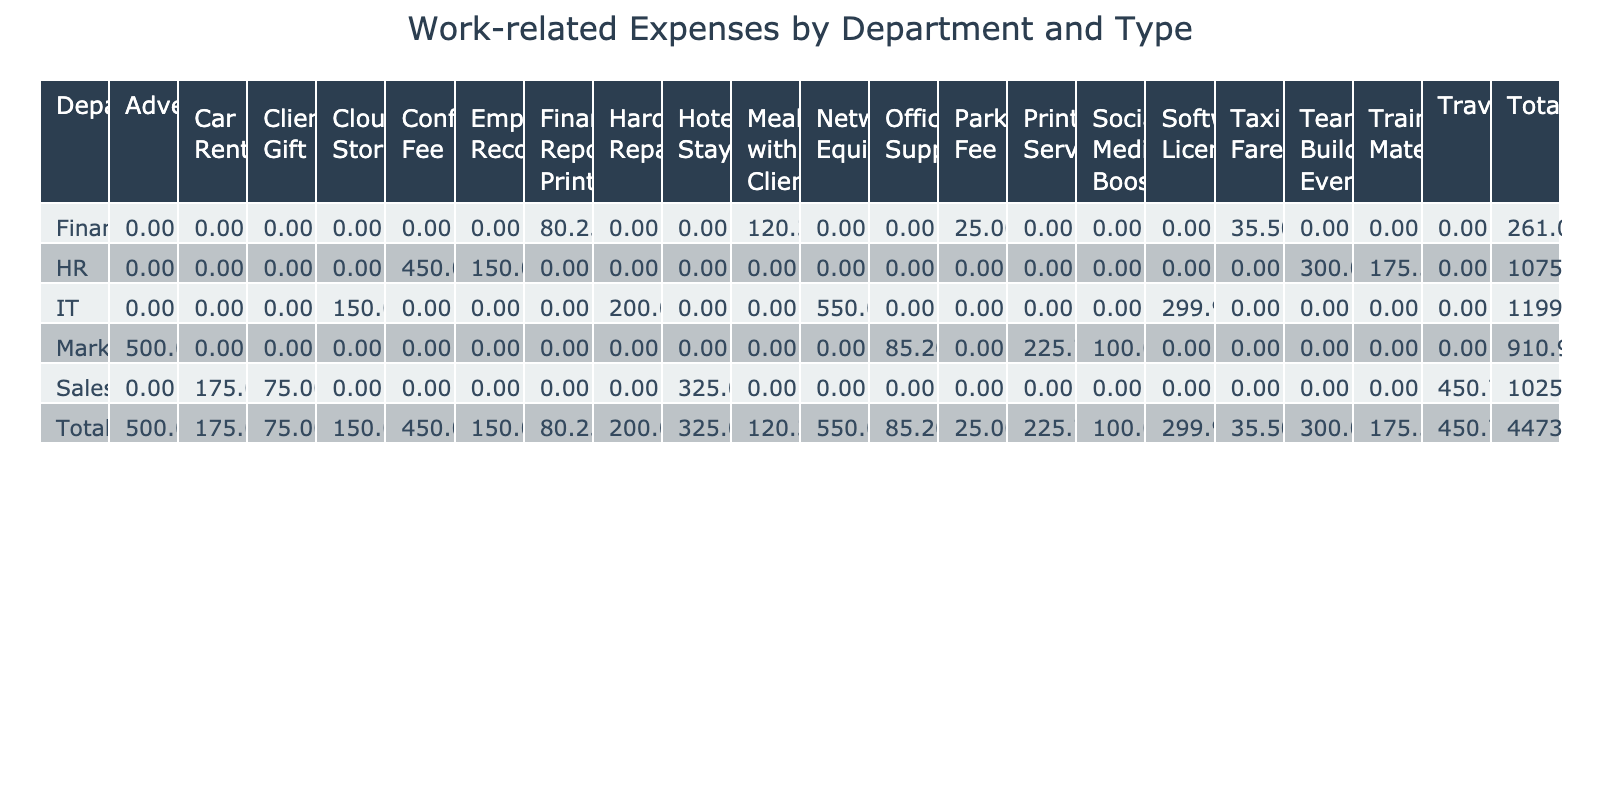What is the total amount spent by the HR department? The HR department has three entries: Training Materials for 175.50, Conference Fee for 450.00, and Employee Recognition for 150.00. Adding these amounts together gives 175.50 + 450.00 + 150.00 = 775.50.
Answer: 775.50 Which department had the highest total expenses? By inspecting the total column in the table, the IT department has the highest total at 1,665.00. The totals for each department are: Sales 1,026.75, Marketing 911.95, IT 1,665.00, HR 775.50, and Finance 260.80.
Answer: IT Was the expense for the Hotel Stay in the Sales department reimbursed? Checking the reimbursement column for the Hotel Stay expense in the Sales department, it shows "Yes," indicating that it was reimbursed.
Answer: Yes What is the total amount of expenses that were not reimbursed? Looking at the table, the only non-reimbursed expense is the Hardware Repair from the IT department, which amounts to 200.00. Therefore, the total amount of non-reimbursed expenses is 200.00.
Answer: 200.00 Calculate the average expense amount for the Marketing department. There are four entries for the Marketing department: Office Supplies (85.20), Advertising (500.00), Printing Services (225.75), and Social Media Boost (100.00). Summing these amounts gives 85.20 + 500.00 + 225.75 + 100.00 = 911.95, and dividing by the number of entries (4) results in an average of 911.95 / 4 = 227.99.
Answer: 227.99 How many employees in the Finance department had expenses reimbursed? In the Finance department, there are four expenses listed: Meal with Client, Taxi Fare, Parking Fee, and Financial Report Printing, all of which are marked as reimbursed. Therefore, the total number of reimbursed expenses is 4.
Answer: 4 Which department had a higher total between Sales and Marketing? The total expenses for Sales amount to 1,026.75, while the Marketing department totals 911.95. Since 1,026.75 is greater than 911.95, Sales had a higher total expense amount.
Answer: Sales What percentage of expenses in the IT department were reimbursed? The IT department has a total of four entries: Software License (299.99) - reimbursed, Hardware Repair (200.00) - not reimbursed, Cloud Storage (150.00) - reimbursed, and Network Equipment (550.00) - reimbursed. Therefore, 3 out of 4 entries were reimbursed, which is 3/4 = 0.75 or 75%.
Answer: 75% How much did employees spend on Travel in total? The table indicates that there are two entries in the Travel category under the Sales department: John Smith (450.75) and Thomas Anderson (175.00). Adding these amounts gives 450.75 + 175.00 = 625.75.
Answer: 625.75 